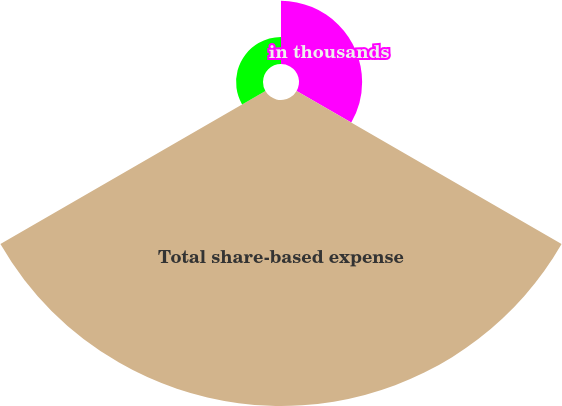Convert chart. <chart><loc_0><loc_0><loc_500><loc_500><pie_chart><fcel>in thousands<fcel>Total share-based expense<fcel>Income tax benefit related to<nl><fcel>15.94%<fcel>77.26%<fcel>6.8%<nl></chart> 